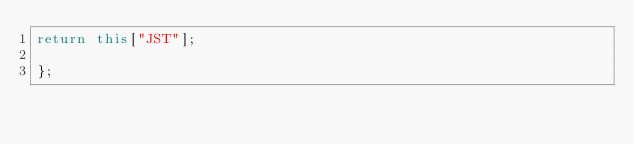Convert code to text. <code><loc_0><loc_0><loc_500><loc_500><_JavaScript_>return this["JST"];

};
</code> 